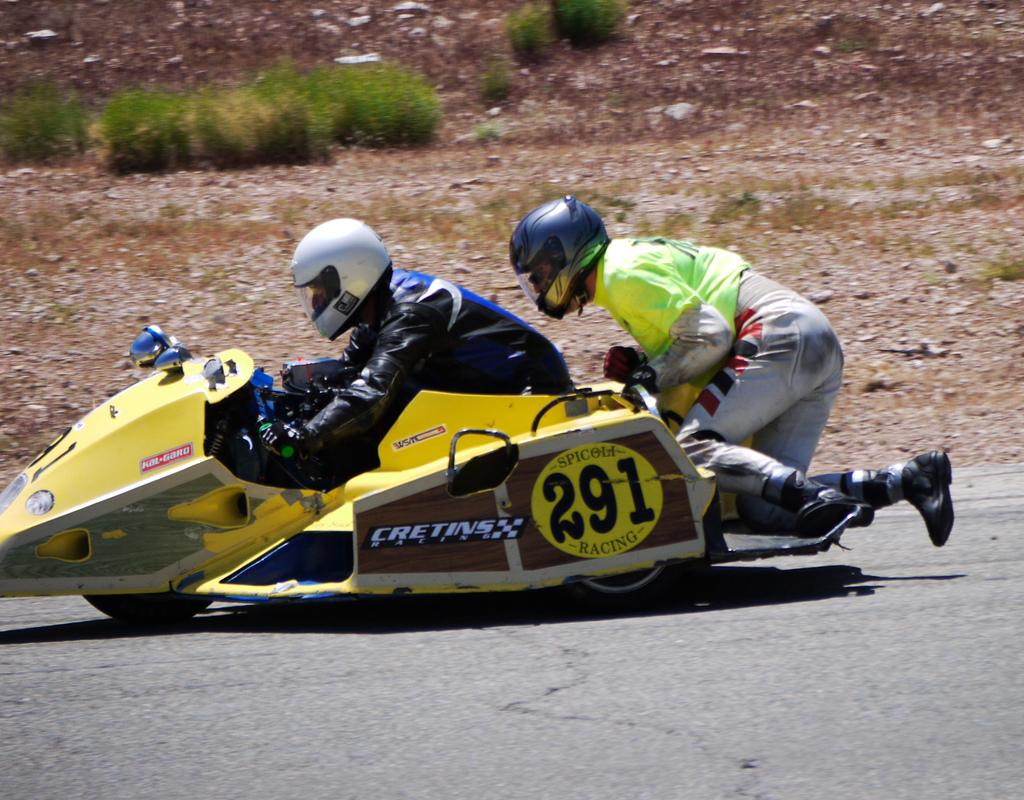How many people are in the image? There are two persons in the image. What are the two persons doing in the image? The two persons are riding a vehicle. Where is the vehicle located in the image? The vehicle is on the road. What can be seen in the background of the image? There is grass, plants, and stones in the background of the image. When was the image taken? The image was taken during the day. Can you see any visible veins on the persons in the image? There is no information about the visibility of veins on the persons in the image. Are the two persons trying to maintain their balance while riding the vehicle? There is no information about the balance of the persons in the image. Are there any police officers present in the image? There is no mention of police officers in the image. 